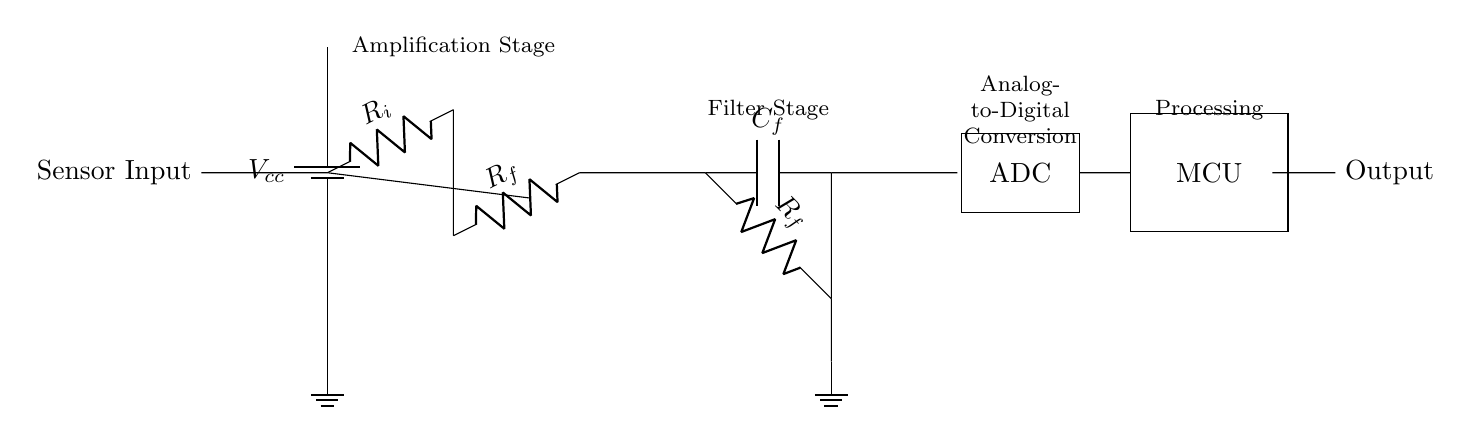What type of circuit is this? This circuit is an analog circuit designed for amplifying and filtering signals from a sensor before converting the signal into a digital format for processing.
Answer: Analog What component provides amplification in this circuit? The operational amplifier in the amplification stage is responsible for boosting the input signal from the sensor.
Answer: Operational amplifier What voltage is supplied in this circuit? The circuit is powered by a battery, which typically provides a voltage that is denoted as V sub cc; the specific value is not given in the diagram itself.
Answer: V cc How many resistors are present in the circuit diagram? The circuit has three resistors: R i, R f in the amplification stage, and R f in the filter stage.
Answer: Three Where does the analog-to-digital conversion take place? The analog-to-digital conversion occurs in the block labeled "ADC" in the circuit, which takes the filtered analog signal and converts it into a digital signal for the microcontroller.
Answer: ADC What is the function of the capacitor in this circuit? The capacitor labeled C f in the filter stage is used to smooth the output from the amplifier by filtering out high-frequency noise, ensuring a cleaner analog signal is sent to the ADC.
Answer: Filtering What is the final output of this analog circuit? The output of the circuit is a digital signal, processed by the microcontroller after being converted from analog by the ADC.
Answer: Digital signal 